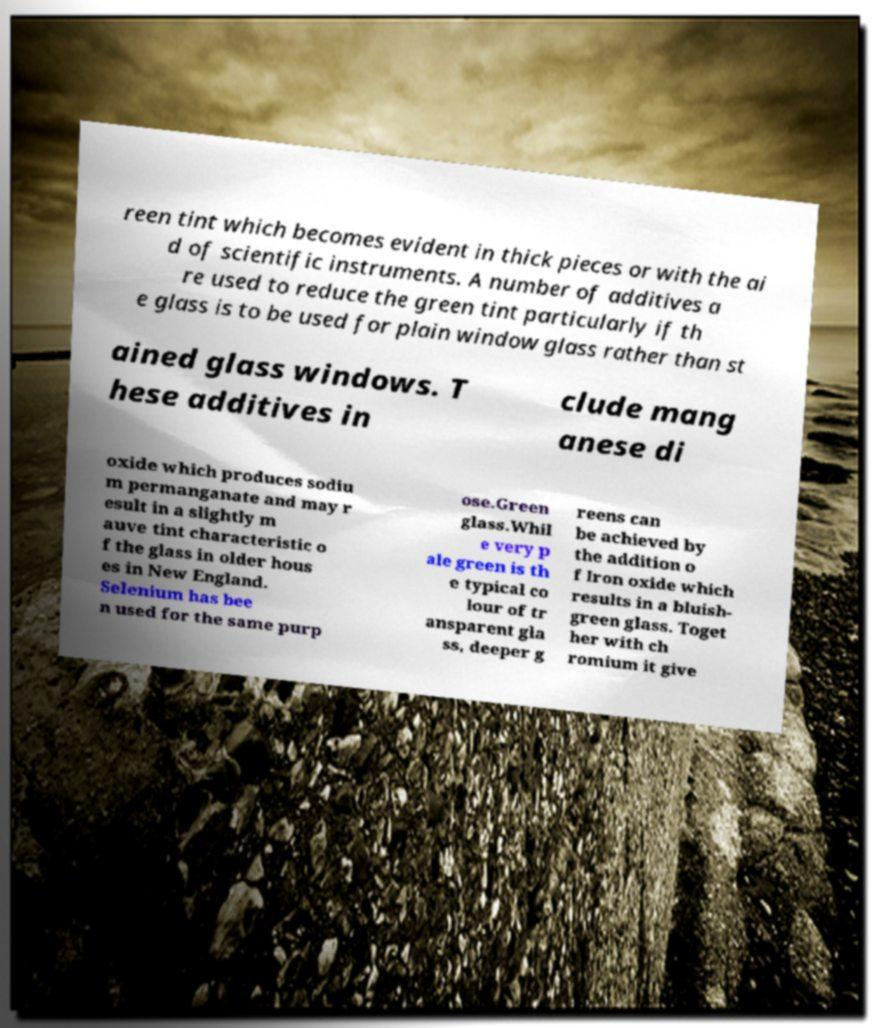Please read and relay the text visible in this image. What does it say? reen tint which becomes evident in thick pieces or with the ai d of scientific instruments. A number of additives a re used to reduce the green tint particularly if th e glass is to be used for plain window glass rather than st ained glass windows. T hese additives in clude mang anese di oxide which produces sodiu m permanganate and may r esult in a slightly m auve tint characteristic o f the glass in older hous es in New England. Selenium has bee n used for the same purp ose.Green glass.Whil e very p ale green is th e typical co lour of tr ansparent gla ss, deeper g reens can be achieved by the addition o f Iron oxide which results in a bluish- green glass. Toget her with ch romium it give 